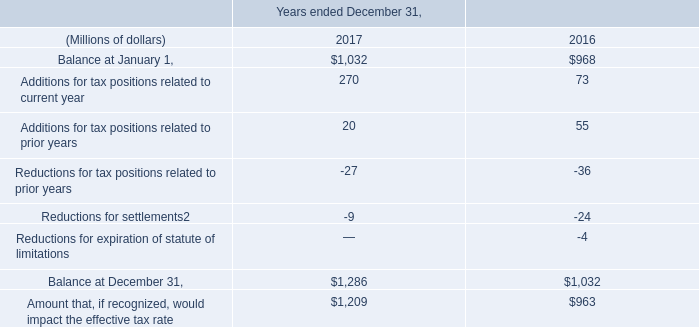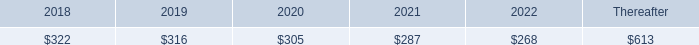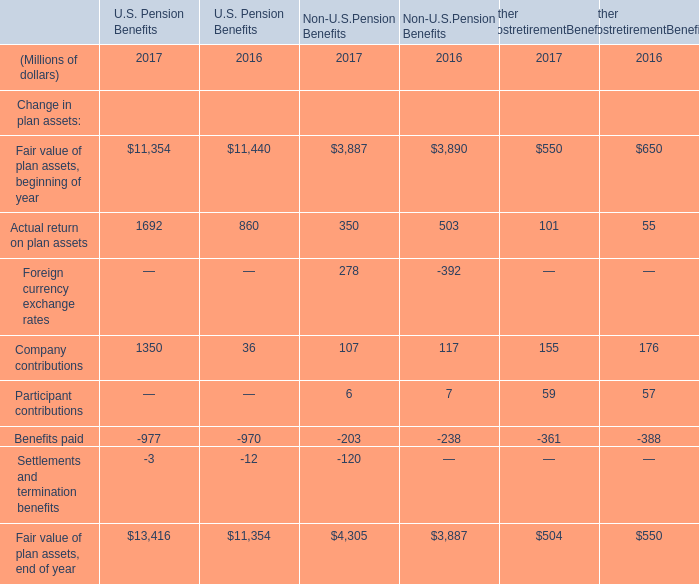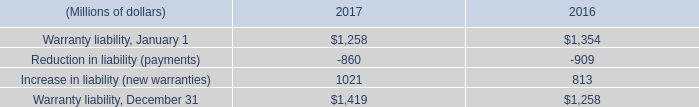what is the percentage change net provision for interest and penalties from 2015 to 2016? 
Computations: ((34 - 20) / 20)
Answer: 0.7. 